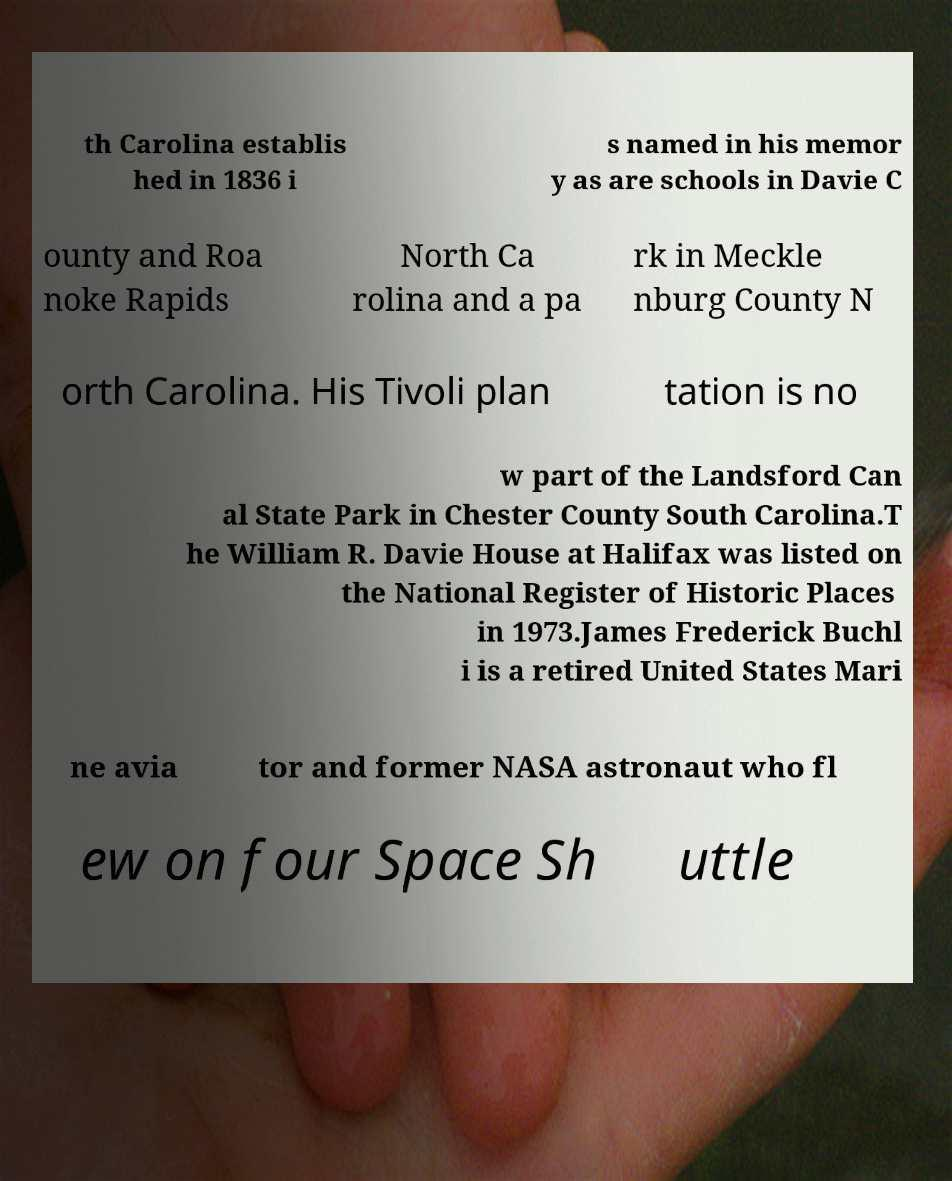Please identify and transcribe the text found in this image. th Carolina establis hed in 1836 i s named in his memor y as are schools in Davie C ounty and Roa noke Rapids North Ca rolina and a pa rk in Meckle nburg County N orth Carolina. His Tivoli plan tation is no w part of the Landsford Can al State Park in Chester County South Carolina.T he William R. Davie House at Halifax was listed on the National Register of Historic Places in 1973.James Frederick Buchl i is a retired United States Mari ne avia tor and former NASA astronaut who fl ew on four Space Sh uttle 